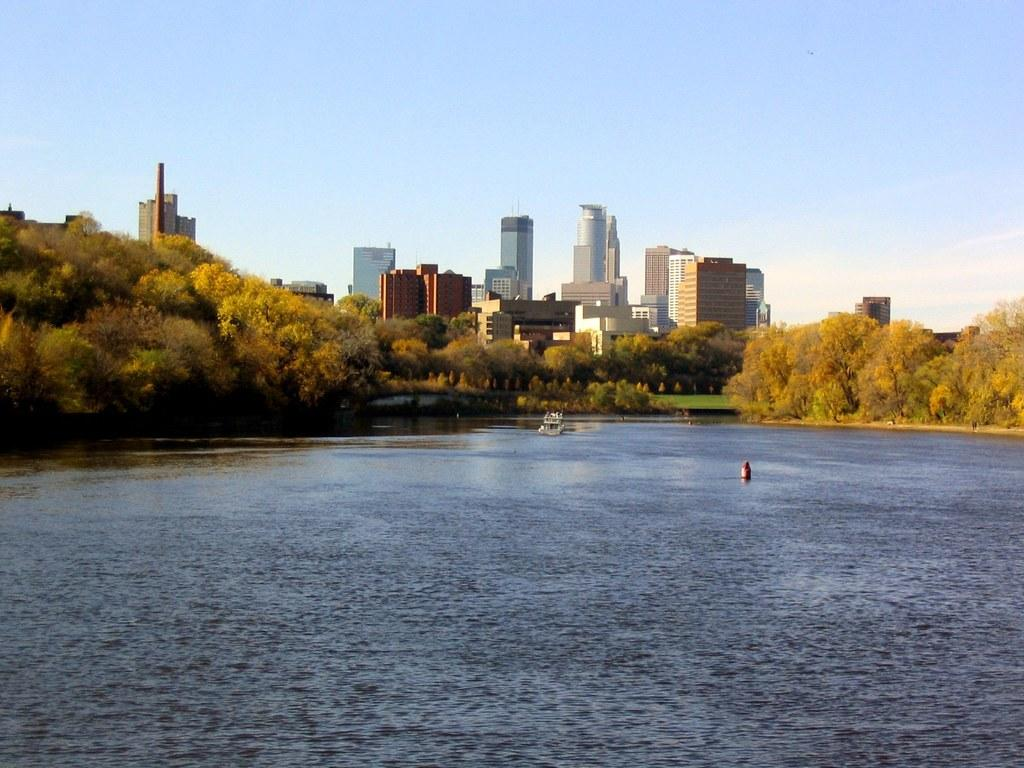What is the primary element visible in the image? There is water in the image. What type of natural vegetation can be seen in the image? There are trees in the image. What type of man-made structures are visible in the background? There are buildings visible in the background. What is located inside the water in the image? There is an object inside the water. What is the color of the sky in the image? The sky is blue and white in color. What type of hammer is being used to create trouble in the image? There is no hammer or any indication of trouble present in the image. 